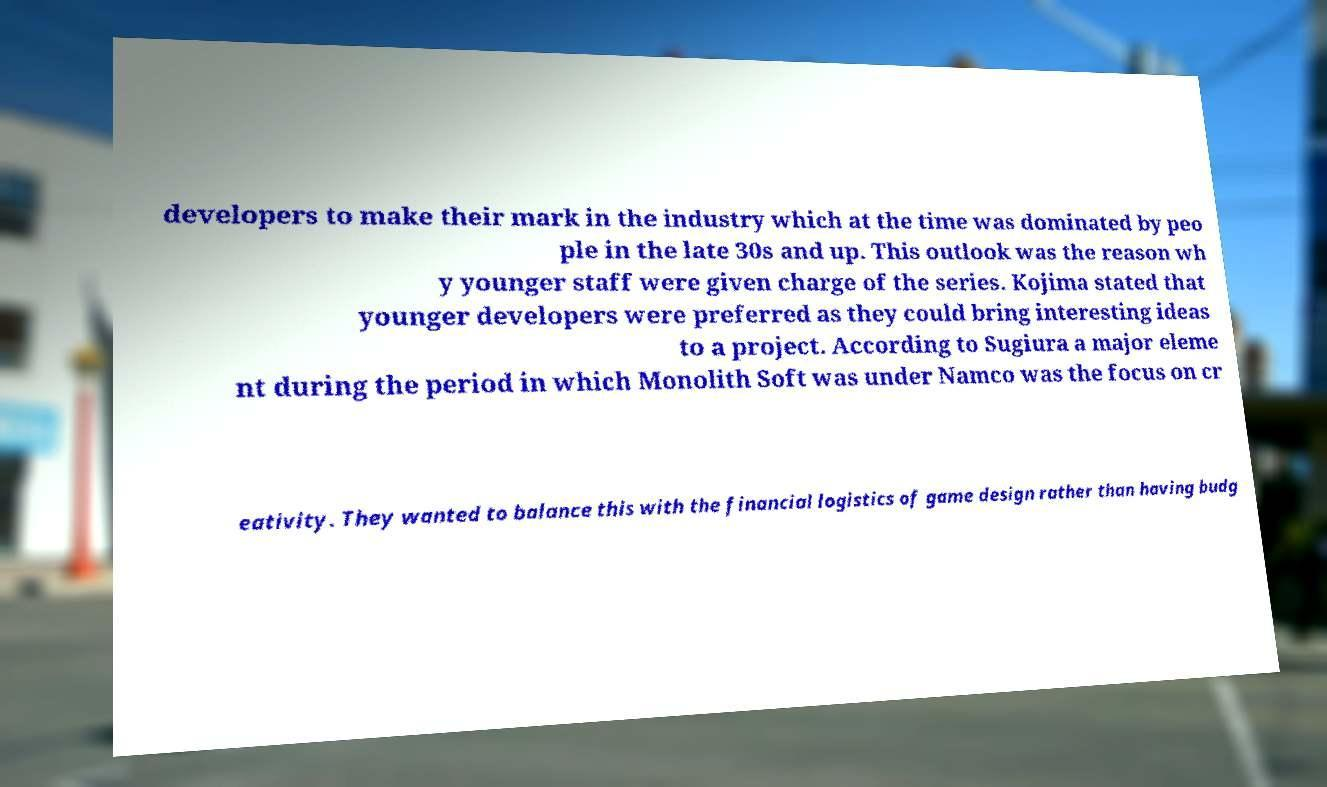I need the written content from this picture converted into text. Can you do that? developers to make their mark in the industry which at the time was dominated by peo ple in the late 30s and up. This outlook was the reason wh y younger staff were given charge of the series. Kojima stated that younger developers were preferred as they could bring interesting ideas to a project. According to Sugiura a major eleme nt during the period in which Monolith Soft was under Namco was the focus on cr eativity. They wanted to balance this with the financial logistics of game design rather than having budg 